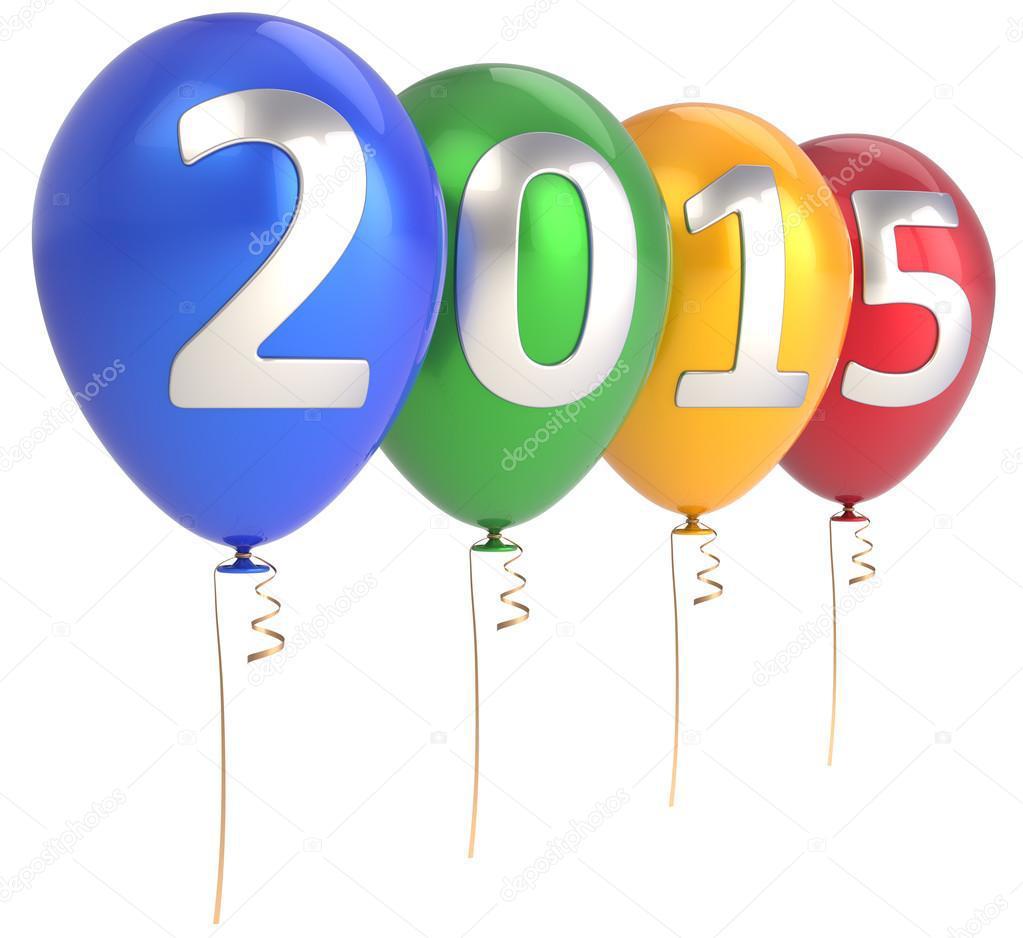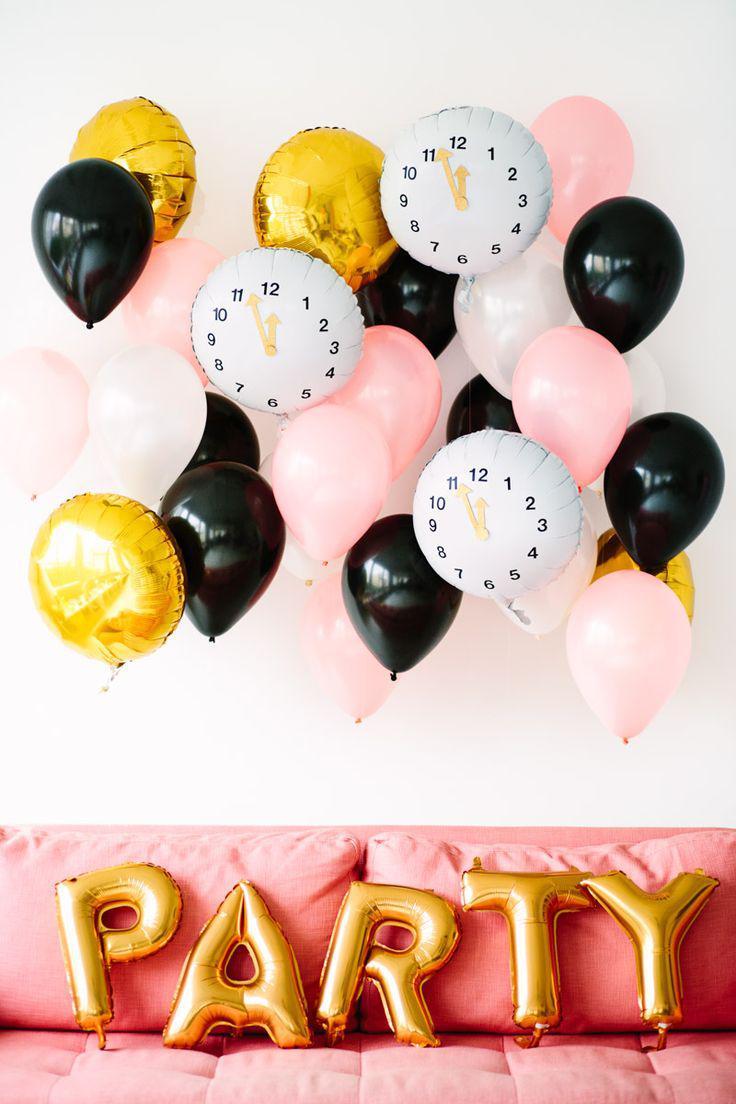The first image is the image on the left, the second image is the image on the right. Given the left and right images, does the statement "Some balloons have faces." hold true? Answer yes or no. No. The first image is the image on the left, the second image is the image on the right. Examine the images to the left and right. Is the description "Both images have letters." accurate? Answer yes or no. No. 